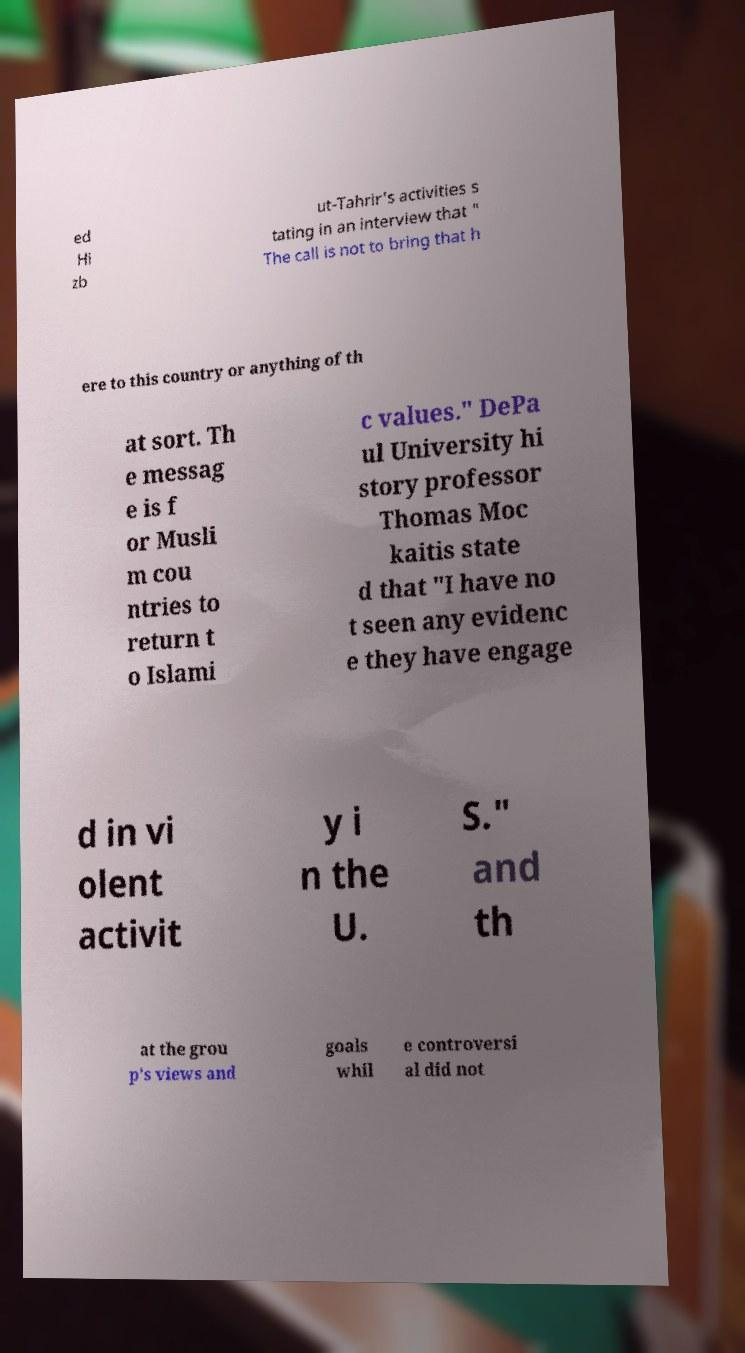What messages or text are displayed in this image? I need them in a readable, typed format. ed Hi zb ut-Tahrir's activities s tating in an interview that " The call is not to bring that h ere to this country or anything of th at sort. Th e messag e is f or Musli m cou ntries to return t o Islami c values." DePa ul University hi story professor Thomas Moc kaitis state d that "I have no t seen any evidenc e they have engage d in vi olent activit y i n the U. S." and th at the grou p's views and goals whil e controversi al did not 